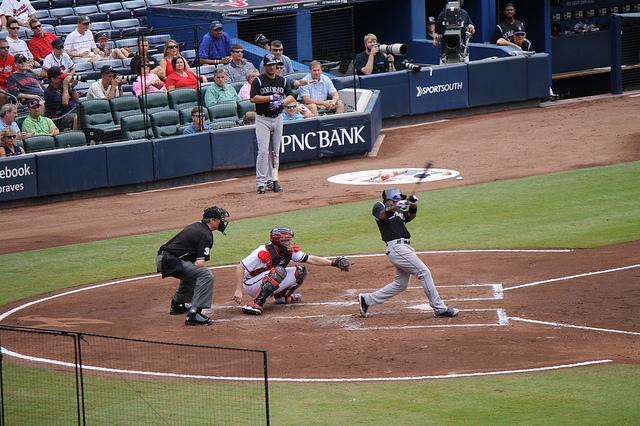Which game is being played?
Keep it brief. Baseball. What team is playing?
Concise answer only. Colorado. What handed is the batter batting?
Write a very short answer. Left. Which bank is being advertised?
Answer briefly. Pnc. 